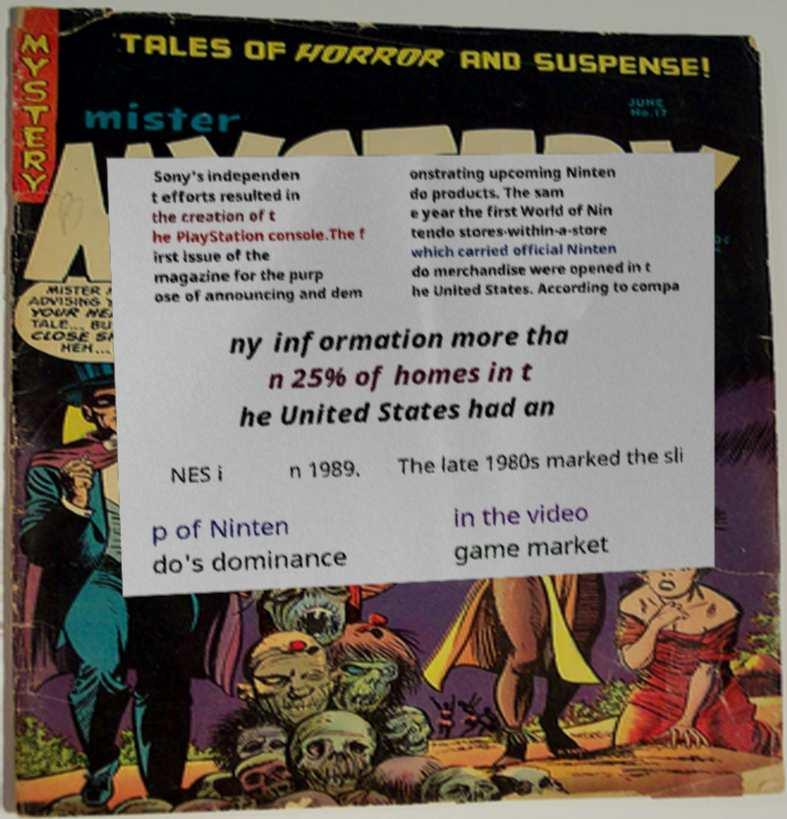Could you assist in decoding the text presented in this image and type it out clearly? Sony's independen t efforts resulted in the creation of t he PlayStation console.The f irst issue of the magazine for the purp ose of announcing and dem onstrating upcoming Ninten do products. The sam e year the first World of Nin tendo stores-within-a-store which carried official Ninten do merchandise were opened in t he United States. According to compa ny information more tha n 25% of homes in t he United States had an NES i n 1989. The late 1980s marked the sli p of Ninten do's dominance in the video game market 